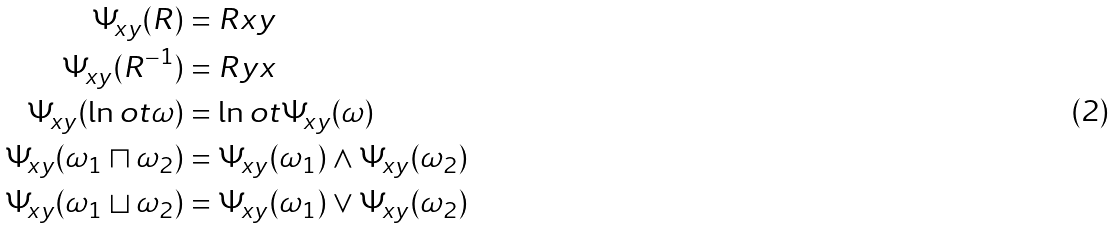<formula> <loc_0><loc_0><loc_500><loc_500>\Psi _ { x y } ( R ) & = R x y \\ \Psi _ { x y } ( R ^ { - 1 } ) & = R y x \\ \Psi _ { x y } ( \ln o t \omega ) & = \ln o t \Psi _ { x y } ( \omega ) \\ \Psi _ { x y } ( \omega _ { 1 } \sqcap \omega _ { 2 } ) & = \Psi _ { x y } ( \omega _ { 1 } ) \land \Psi _ { x y } ( \omega _ { 2 } ) \\ \Psi _ { x y } ( \omega _ { 1 } \sqcup \omega _ { 2 } ) & = \Psi _ { x y } ( \omega _ { 1 } ) \lor \Psi _ { x y } ( \omega _ { 2 } )</formula> 